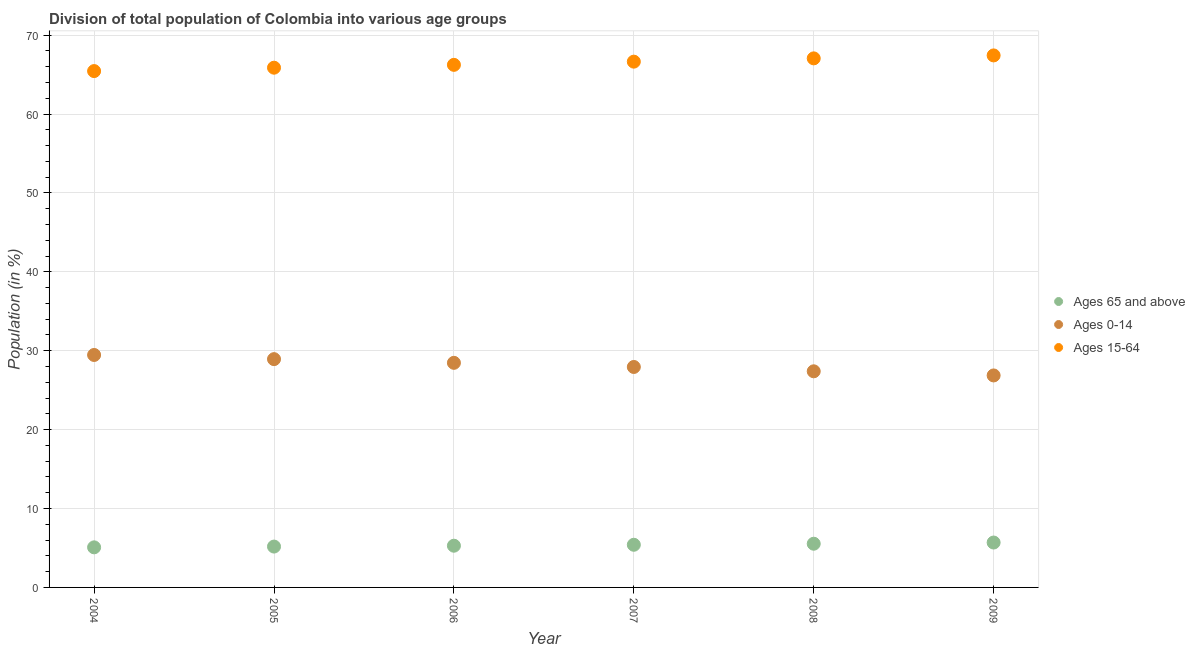How many different coloured dotlines are there?
Provide a succinct answer. 3. Is the number of dotlines equal to the number of legend labels?
Offer a terse response. Yes. What is the percentage of population within the age-group 0-14 in 2005?
Provide a succinct answer. 28.94. Across all years, what is the maximum percentage of population within the age-group 0-14?
Provide a succinct answer. 29.47. Across all years, what is the minimum percentage of population within the age-group 0-14?
Your answer should be compact. 26.87. In which year was the percentage of population within the age-group of 65 and above maximum?
Your response must be concise. 2009. What is the total percentage of population within the age-group 15-64 in the graph?
Give a very brief answer. 398.73. What is the difference between the percentage of population within the age-group 0-14 in 2004 and that in 2008?
Your answer should be compact. 2.07. What is the difference between the percentage of population within the age-group 15-64 in 2006 and the percentage of population within the age-group of 65 and above in 2004?
Your answer should be compact. 61.16. What is the average percentage of population within the age-group 0-14 per year?
Ensure brevity in your answer.  28.18. In the year 2005, what is the difference between the percentage of population within the age-group 15-64 and percentage of population within the age-group of 65 and above?
Your response must be concise. 60.7. In how many years, is the percentage of population within the age-group of 65 and above greater than 8 %?
Give a very brief answer. 0. What is the ratio of the percentage of population within the age-group 0-14 in 2007 to that in 2008?
Offer a terse response. 1.02. What is the difference between the highest and the second highest percentage of population within the age-group 15-64?
Give a very brief answer. 0.37. What is the difference between the highest and the lowest percentage of population within the age-group 0-14?
Provide a short and direct response. 2.59. In how many years, is the percentage of population within the age-group of 65 and above greater than the average percentage of population within the age-group of 65 and above taken over all years?
Your response must be concise. 3. Is the sum of the percentage of population within the age-group 15-64 in 2005 and 2008 greater than the maximum percentage of population within the age-group of 65 and above across all years?
Provide a short and direct response. Yes. Is it the case that in every year, the sum of the percentage of population within the age-group of 65 and above and percentage of population within the age-group 0-14 is greater than the percentage of population within the age-group 15-64?
Make the answer very short. No. Does the percentage of population within the age-group 0-14 monotonically increase over the years?
Your answer should be compact. No. Is the percentage of population within the age-group 0-14 strictly greater than the percentage of population within the age-group of 65 and above over the years?
Ensure brevity in your answer.  Yes. How many dotlines are there?
Keep it short and to the point. 3. What is the difference between two consecutive major ticks on the Y-axis?
Ensure brevity in your answer.  10. Are the values on the major ticks of Y-axis written in scientific E-notation?
Ensure brevity in your answer.  No. Does the graph contain any zero values?
Offer a very short reply. No. Where does the legend appear in the graph?
Keep it short and to the point. Center right. What is the title of the graph?
Your answer should be compact. Division of total population of Colombia into various age groups
. What is the label or title of the X-axis?
Your answer should be compact. Year. What is the Population (in %) in Ages 65 and above in 2004?
Keep it short and to the point. 5.08. What is the Population (in %) of Ages 0-14 in 2004?
Provide a succinct answer. 29.47. What is the Population (in %) in Ages 15-64 in 2004?
Your answer should be compact. 65.45. What is the Population (in %) of Ages 65 and above in 2005?
Provide a succinct answer. 5.18. What is the Population (in %) of Ages 0-14 in 2005?
Provide a short and direct response. 28.94. What is the Population (in %) of Ages 15-64 in 2005?
Offer a terse response. 65.88. What is the Population (in %) of Ages 65 and above in 2006?
Keep it short and to the point. 5.29. What is the Population (in %) in Ages 0-14 in 2006?
Your answer should be compact. 28.47. What is the Population (in %) of Ages 15-64 in 2006?
Provide a short and direct response. 66.24. What is the Population (in %) of Ages 65 and above in 2007?
Make the answer very short. 5.41. What is the Population (in %) of Ages 0-14 in 2007?
Keep it short and to the point. 27.95. What is the Population (in %) of Ages 15-64 in 2007?
Offer a very short reply. 66.65. What is the Population (in %) in Ages 65 and above in 2008?
Ensure brevity in your answer.  5.54. What is the Population (in %) in Ages 0-14 in 2008?
Your answer should be compact. 27.4. What is the Population (in %) in Ages 15-64 in 2008?
Your response must be concise. 67.06. What is the Population (in %) in Ages 65 and above in 2009?
Make the answer very short. 5.69. What is the Population (in %) in Ages 0-14 in 2009?
Provide a short and direct response. 26.87. What is the Population (in %) of Ages 15-64 in 2009?
Make the answer very short. 67.44. Across all years, what is the maximum Population (in %) in Ages 65 and above?
Give a very brief answer. 5.69. Across all years, what is the maximum Population (in %) of Ages 0-14?
Your answer should be very brief. 29.47. Across all years, what is the maximum Population (in %) of Ages 15-64?
Offer a terse response. 67.44. Across all years, what is the minimum Population (in %) of Ages 65 and above?
Keep it short and to the point. 5.08. Across all years, what is the minimum Population (in %) in Ages 0-14?
Your answer should be very brief. 26.87. Across all years, what is the minimum Population (in %) of Ages 15-64?
Provide a succinct answer. 65.45. What is the total Population (in %) of Ages 65 and above in the graph?
Give a very brief answer. 32.19. What is the total Population (in %) of Ages 0-14 in the graph?
Your answer should be very brief. 169.09. What is the total Population (in %) of Ages 15-64 in the graph?
Give a very brief answer. 398.73. What is the difference between the Population (in %) in Ages 65 and above in 2004 and that in 2005?
Your response must be concise. -0.1. What is the difference between the Population (in %) of Ages 0-14 in 2004 and that in 2005?
Offer a terse response. 0.53. What is the difference between the Population (in %) in Ages 15-64 in 2004 and that in 2005?
Make the answer very short. -0.43. What is the difference between the Population (in %) in Ages 65 and above in 2004 and that in 2006?
Offer a very short reply. -0.21. What is the difference between the Population (in %) in Ages 15-64 in 2004 and that in 2006?
Offer a very short reply. -0.79. What is the difference between the Population (in %) of Ages 65 and above in 2004 and that in 2007?
Make the answer very short. -0.33. What is the difference between the Population (in %) of Ages 0-14 in 2004 and that in 2007?
Make the answer very short. 1.52. What is the difference between the Population (in %) of Ages 15-64 in 2004 and that in 2007?
Your response must be concise. -1.2. What is the difference between the Population (in %) in Ages 65 and above in 2004 and that in 2008?
Your answer should be very brief. -0.46. What is the difference between the Population (in %) of Ages 0-14 in 2004 and that in 2008?
Ensure brevity in your answer.  2.07. What is the difference between the Population (in %) of Ages 15-64 in 2004 and that in 2008?
Provide a short and direct response. -1.61. What is the difference between the Population (in %) of Ages 65 and above in 2004 and that in 2009?
Your response must be concise. -0.61. What is the difference between the Population (in %) of Ages 0-14 in 2004 and that in 2009?
Offer a very short reply. 2.59. What is the difference between the Population (in %) in Ages 15-64 in 2004 and that in 2009?
Make the answer very short. -1.99. What is the difference between the Population (in %) of Ages 65 and above in 2005 and that in 2006?
Your response must be concise. -0.11. What is the difference between the Population (in %) in Ages 0-14 in 2005 and that in 2006?
Provide a succinct answer. 0.47. What is the difference between the Population (in %) of Ages 15-64 in 2005 and that in 2006?
Provide a short and direct response. -0.36. What is the difference between the Population (in %) in Ages 65 and above in 2005 and that in 2007?
Give a very brief answer. -0.23. What is the difference between the Population (in %) in Ages 0-14 in 2005 and that in 2007?
Your response must be concise. 0.99. What is the difference between the Population (in %) in Ages 15-64 in 2005 and that in 2007?
Your response must be concise. -0.77. What is the difference between the Population (in %) of Ages 65 and above in 2005 and that in 2008?
Your response must be concise. -0.36. What is the difference between the Population (in %) in Ages 0-14 in 2005 and that in 2008?
Give a very brief answer. 1.54. What is the difference between the Population (in %) in Ages 15-64 in 2005 and that in 2008?
Your response must be concise. -1.18. What is the difference between the Population (in %) in Ages 65 and above in 2005 and that in 2009?
Your answer should be very brief. -0.51. What is the difference between the Population (in %) of Ages 0-14 in 2005 and that in 2009?
Offer a terse response. 2.07. What is the difference between the Population (in %) in Ages 15-64 in 2005 and that in 2009?
Provide a short and direct response. -1.56. What is the difference between the Population (in %) of Ages 65 and above in 2006 and that in 2007?
Your answer should be compact. -0.12. What is the difference between the Population (in %) in Ages 0-14 in 2006 and that in 2007?
Offer a very short reply. 0.52. What is the difference between the Population (in %) in Ages 15-64 in 2006 and that in 2007?
Your answer should be very brief. -0.41. What is the difference between the Population (in %) in Ages 65 and above in 2006 and that in 2008?
Ensure brevity in your answer.  -0.25. What is the difference between the Population (in %) in Ages 0-14 in 2006 and that in 2008?
Provide a succinct answer. 1.07. What is the difference between the Population (in %) of Ages 15-64 in 2006 and that in 2008?
Keep it short and to the point. -0.82. What is the difference between the Population (in %) of Ages 65 and above in 2006 and that in 2009?
Offer a very short reply. -0.4. What is the difference between the Population (in %) in Ages 0-14 in 2006 and that in 2009?
Ensure brevity in your answer.  1.6. What is the difference between the Population (in %) of Ages 15-64 in 2006 and that in 2009?
Keep it short and to the point. -1.2. What is the difference between the Population (in %) of Ages 65 and above in 2007 and that in 2008?
Offer a terse response. -0.13. What is the difference between the Population (in %) of Ages 0-14 in 2007 and that in 2008?
Your response must be concise. 0.55. What is the difference between the Population (in %) of Ages 15-64 in 2007 and that in 2008?
Ensure brevity in your answer.  -0.42. What is the difference between the Population (in %) in Ages 65 and above in 2007 and that in 2009?
Provide a short and direct response. -0.28. What is the difference between the Population (in %) in Ages 0-14 in 2007 and that in 2009?
Your response must be concise. 1.07. What is the difference between the Population (in %) in Ages 15-64 in 2007 and that in 2009?
Give a very brief answer. -0.79. What is the difference between the Population (in %) of Ages 65 and above in 2008 and that in 2009?
Make the answer very short. -0.15. What is the difference between the Population (in %) of Ages 0-14 in 2008 and that in 2009?
Make the answer very short. 0.52. What is the difference between the Population (in %) in Ages 15-64 in 2008 and that in 2009?
Your answer should be compact. -0.37. What is the difference between the Population (in %) of Ages 65 and above in 2004 and the Population (in %) of Ages 0-14 in 2005?
Make the answer very short. -23.86. What is the difference between the Population (in %) in Ages 65 and above in 2004 and the Population (in %) in Ages 15-64 in 2005?
Ensure brevity in your answer.  -60.8. What is the difference between the Population (in %) in Ages 0-14 in 2004 and the Population (in %) in Ages 15-64 in 2005?
Give a very brief answer. -36.42. What is the difference between the Population (in %) of Ages 65 and above in 2004 and the Population (in %) of Ages 0-14 in 2006?
Provide a succinct answer. -23.39. What is the difference between the Population (in %) in Ages 65 and above in 2004 and the Population (in %) in Ages 15-64 in 2006?
Provide a short and direct response. -61.16. What is the difference between the Population (in %) of Ages 0-14 in 2004 and the Population (in %) of Ages 15-64 in 2006?
Offer a terse response. -36.78. What is the difference between the Population (in %) of Ages 65 and above in 2004 and the Population (in %) of Ages 0-14 in 2007?
Provide a short and direct response. -22.86. What is the difference between the Population (in %) of Ages 65 and above in 2004 and the Population (in %) of Ages 15-64 in 2007?
Your answer should be compact. -61.57. What is the difference between the Population (in %) in Ages 0-14 in 2004 and the Population (in %) in Ages 15-64 in 2007?
Offer a very short reply. -37.18. What is the difference between the Population (in %) of Ages 65 and above in 2004 and the Population (in %) of Ages 0-14 in 2008?
Your response must be concise. -22.32. What is the difference between the Population (in %) of Ages 65 and above in 2004 and the Population (in %) of Ages 15-64 in 2008?
Keep it short and to the point. -61.98. What is the difference between the Population (in %) in Ages 0-14 in 2004 and the Population (in %) in Ages 15-64 in 2008?
Make the answer very short. -37.6. What is the difference between the Population (in %) in Ages 65 and above in 2004 and the Population (in %) in Ages 0-14 in 2009?
Make the answer very short. -21.79. What is the difference between the Population (in %) of Ages 65 and above in 2004 and the Population (in %) of Ages 15-64 in 2009?
Provide a succinct answer. -62.36. What is the difference between the Population (in %) of Ages 0-14 in 2004 and the Population (in %) of Ages 15-64 in 2009?
Your answer should be very brief. -37.97. What is the difference between the Population (in %) of Ages 65 and above in 2005 and the Population (in %) of Ages 0-14 in 2006?
Make the answer very short. -23.29. What is the difference between the Population (in %) in Ages 65 and above in 2005 and the Population (in %) in Ages 15-64 in 2006?
Your response must be concise. -61.06. What is the difference between the Population (in %) in Ages 0-14 in 2005 and the Population (in %) in Ages 15-64 in 2006?
Your response must be concise. -37.3. What is the difference between the Population (in %) of Ages 65 and above in 2005 and the Population (in %) of Ages 0-14 in 2007?
Your answer should be compact. -22.77. What is the difference between the Population (in %) in Ages 65 and above in 2005 and the Population (in %) in Ages 15-64 in 2007?
Provide a succinct answer. -61.47. What is the difference between the Population (in %) in Ages 0-14 in 2005 and the Population (in %) in Ages 15-64 in 2007?
Ensure brevity in your answer.  -37.71. What is the difference between the Population (in %) in Ages 65 and above in 2005 and the Population (in %) in Ages 0-14 in 2008?
Ensure brevity in your answer.  -22.22. What is the difference between the Population (in %) in Ages 65 and above in 2005 and the Population (in %) in Ages 15-64 in 2008?
Provide a short and direct response. -61.88. What is the difference between the Population (in %) of Ages 0-14 in 2005 and the Population (in %) of Ages 15-64 in 2008?
Give a very brief answer. -38.12. What is the difference between the Population (in %) in Ages 65 and above in 2005 and the Population (in %) in Ages 0-14 in 2009?
Offer a very short reply. -21.69. What is the difference between the Population (in %) in Ages 65 and above in 2005 and the Population (in %) in Ages 15-64 in 2009?
Your response must be concise. -62.26. What is the difference between the Population (in %) of Ages 0-14 in 2005 and the Population (in %) of Ages 15-64 in 2009?
Give a very brief answer. -38.5. What is the difference between the Population (in %) of Ages 65 and above in 2006 and the Population (in %) of Ages 0-14 in 2007?
Ensure brevity in your answer.  -22.66. What is the difference between the Population (in %) of Ages 65 and above in 2006 and the Population (in %) of Ages 15-64 in 2007?
Make the answer very short. -61.36. What is the difference between the Population (in %) of Ages 0-14 in 2006 and the Population (in %) of Ages 15-64 in 2007?
Make the answer very short. -38.18. What is the difference between the Population (in %) in Ages 65 and above in 2006 and the Population (in %) in Ages 0-14 in 2008?
Offer a very short reply. -22.11. What is the difference between the Population (in %) of Ages 65 and above in 2006 and the Population (in %) of Ages 15-64 in 2008?
Offer a terse response. -61.78. What is the difference between the Population (in %) of Ages 0-14 in 2006 and the Population (in %) of Ages 15-64 in 2008?
Make the answer very short. -38.59. What is the difference between the Population (in %) in Ages 65 and above in 2006 and the Population (in %) in Ages 0-14 in 2009?
Ensure brevity in your answer.  -21.58. What is the difference between the Population (in %) of Ages 65 and above in 2006 and the Population (in %) of Ages 15-64 in 2009?
Keep it short and to the point. -62.15. What is the difference between the Population (in %) of Ages 0-14 in 2006 and the Population (in %) of Ages 15-64 in 2009?
Give a very brief answer. -38.97. What is the difference between the Population (in %) in Ages 65 and above in 2007 and the Population (in %) in Ages 0-14 in 2008?
Keep it short and to the point. -21.99. What is the difference between the Population (in %) of Ages 65 and above in 2007 and the Population (in %) of Ages 15-64 in 2008?
Keep it short and to the point. -61.66. What is the difference between the Population (in %) of Ages 0-14 in 2007 and the Population (in %) of Ages 15-64 in 2008?
Ensure brevity in your answer.  -39.12. What is the difference between the Population (in %) in Ages 65 and above in 2007 and the Population (in %) in Ages 0-14 in 2009?
Provide a short and direct response. -21.46. What is the difference between the Population (in %) in Ages 65 and above in 2007 and the Population (in %) in Ages 15-64 in 2009?
Ensure brevity in your answer.  -62.03. What is the difference between the Population (in %) in Ages 0-14 in 2007 and the Population (in %) in Ages 15-64 in 2009?
Offer a very short reply. -39.49. What is the difference between the Population (in %) in Ages 65 and above in 2008 and the Population (in %) in Ages 0-14 in 2009?
Keep it short and to the point. -21.33. What is the difference between the Population (in %) in Ages 65 and above in 2008 and the Population (in %) in Ages 15-64 in 2009?
Offer a very short reply. -61.9. What is the difference between the Population (in %) in Ages 0-14 in 2008 and the Population (in %) in Ages 15-64 in 2009?
Offer a very short reply. -40.04. What is the average Population (in %) in Ages 65 and above per year?
Your answer should be compact. 5.36. What is the average Population (in %) in Ages 0-14 per year?
Give a very brief answer. 28.18. What is the average Population (in %) of Ages 15-64 per year?
Offer a very short reply. 66.45. In the year 2004, what is the difference between the Population (in %) in Ages 65 and above and Population (in %) in Ages 0-14?
Your answer should be compact. -24.39. In the year 2004, what is the difference between the Population (in %) of Ages 65 and above and Population (in %) of Ages 15-64?
Your response must be concise. -60.37. In the year 2004, what is the difference between the Population (in %) in Ages 0-14 and Population (in %) in Ages 15-64?
Offer a terse response. -35.99. In the year 2005, what is the difference between the Population (in %) in Ages 65 and above and Population (in %) in Ages 0-14?
Ensure brevity in your answer.  -23.76. In the year 2005, what is the difference between the Population (in %) of Ages 65 and above and Population (in %) of Ages 15-64?
Keep it short and to the point. -60.7. In the year 2005, what is the difference between the Population (in %) of Ages 0-14 and Population (in %) of Ages 15-64?
Offer a very short reply. -36.94. In the year 2006, what is the difference between the Population (in %) of Ages 65 and above and Population (in %) of Ages 0-14?
Give a very brief answer. -23.18. In the year 2006, what is the difference between the Population (in %) of Ages 65 and above and Population (in %) of Ages 15-64?
Offer a terse response. -60.95. In the year 2006, what is the difference between the Population (in %) of Ages 0-14 and Population (in %) of Ages 15-64?
Your answer should be very brief. -37.77. In the year 2007, what is the difference between the Population (in %) in Ages 65 and above and Population (in %) in Ages 0-14?
Give a very brief answer. -22.54. In the year 2007, what is the difference between the Population (in %) in Ages 65 and above and Population (in %) in Ages 15-64?
Your answer should be very brief. -61.24. In the year 2007, what is the difference between the Population (in %) of Ages 0-14 and Population (in %) of Ages 15-64?
Your response must be concise. -38.7. In the year 2008, what is the difference between the Population (in %) of Ages 65 and above and Population (in %) of Ages 0-14?
Offer a very short reply. -21.86. In the year 2008, what is the difference between the Population (in %) in Ages 65 and above and Population (in %) in Ages 15-64?
Your answer should be compact. -61.52. In the year 2008, what is the difference between the Population (in %) of Ages 0-14 and Population (in %) of Ages 15-64?
Keep it short and to the point. -39.67. In the year 2009, what is the difference between the Population (in %) in Ages 65 and above and Population (in %) in Ages 0-14?
Give a very brief answer. -21.18. In the year 2009, what is the difference between the Population (in %) of Ages 65 and above and Population (in %) of Ages 15-64?
Provide a succinct answer. -61.75. In the year 2009, what is the difference between the Population (in %) in Ages 0-14 and Population (in %) in Ages 15-64?
Offer a very short reply. -40.57. What is the ratio of the Population (in %) of Ages 65 and above in 2004 to that in 2005?
Offer a very short reply. 0.98. What is the ratio of the Population (in %) in Ages 0-14 in 2004 to that in 2005?
Provide a succinct answer. 1.02. What is the ratio of the Population (in %) of Ages 15-64 in 2004 to that in 2005?
Offer a terse response. 0.99. What is the ratio of the Population (in %) of Ages 65 and above in 2004 to that in 2006?
Make the answer very short. 0.96. What is the ratio of the Population (in %) in Ages 0-14 in 2004 to that in 2006?
Your response must be concise. 1.03. What is the ratio of the Population (in %) of Ages 15-64 in 2004 to that in 2006?
Offer a very short reply. 0.99. What is the ratio of the Population (in %) of Ages 65 and above in 2004 to that in 2007?
Offer a terse response. 0.94. What is the ratio of the Population (in %) in Ages 0-14 in 2004 to that in 2007?
Give a very brief answer. 1.05. What is the ratio of the Population (in %) of Ages 15-64 in 2004 to that in 2007?
Offer a very short reply. 0.98. What is the ratio of the Population (in %) in Ages 65 and above in 2004 to that in 2008?
Offer a terse response. 0.92. What is the ratio of the Population (in %) of Ages 0-14 in 2004 to that in 2008?
Your response must be concise. 1.08. What is the ratio of the Population (in %) of Ages 15-64 in 2004 to that in 2008?
Your answer should be very brief. 0.98. What is the ratio of the Population (in %) of Ages 65 and above in 2004 to that in 2009?
Provide a succinct answer. 0.89. What is the ratio of the Population (in %) of Ages 0-14 in 2004 to that in 2009?
Your answer should be compact. 1.1. What is the ratio of the Population (in %) in Ages 15-64 in 2004 to that in 2009?
Give a very brief answer. 0.97. What is the ratio of the Population (in %) in Ages 65 and above in 2005 to that in 2006?
Your response must be concise. 0.98. What is the ratio of the Population (in %) of Ages 0-14 in 2005 to that in 2006?
Offer a very short reply. 1.02. What is the ratio of the Population (in %) of Ages 15-64 in 2005 to that in 2006?
Your answer should be very brief. 0.99. What is the ratio of the Population (in %) in Ages 65 and above in 2005 to that in 2007?
Give a very brief answer. 0.96. What is the ratio of the Population (in %) of Ages 0-14 in 2005 to that in 2007?
Your answer should be compact. 1.04. What is the ratio of the Population (in %) of Ages 15-64 in 2005 to that in 2007?
Offer a very short reply. 0.99. What is the ratio of the Population (in %) in Ages 65 and above in 2005 to that in 2008?
Keep it short and to the point. 0.93. What is the ratio of the Population (in %) of Ages 0-14 in 2005 to that in 2008?
Provide a succinct answer. 1.06. What is the ratio of the Population (in %) of Ages 15-64 in 2005 to that in 2008?
Offer a terse response. 0.98. What is the ratio of the Population (in %) of Ages 65 and above in 2005 to that in 2009?
Make the answer very short. 0.91. What is the ratio of the Population (in %) of Ages 15-64 in 2005 to that in 2009?
Keep it short and to the point. 0.98. What is the ratio of the Population (in %) in Ages 65 and above in 2006 to that in 2007?
Offer a very short reply. 0.98. What is the ratio of the Population (in %) in Ages 0-14 in 2006 to that in 2007?
Offer a terse response. 1.02. What is the ratio of the Population (in %) in Ages 15-64 in 2006 to that in 2007?
Offer a terse response. 0.99. What is the ratio of the Population (in %) in Ages 65 and above in 2006 to that in 2008?
Make the answer very short. 0.95. What is the ratio of the Population (in %) in Ages 0-14 in 2006 to that in 2008?
Provide a short and direct response. 1.04. What is the ratio of the Population (in %) in Ages 65 and above in 2006 to that in 2009?
Offer a very short reply. 0.93. What is the ratio of the Population (in %) of Ages 0-14 in 2006 to that in 2009?
Offer a terse response. 1.06. What is the ratio of the Population (in %) of Ages 15-64 in 2006 to that in 2009?
Offer a very short reply. 0.98. What is the ratio of the Population (in %) of Ages 15-64 in 2007 to that in 2008?
Provide a short and direct response. 0.99. What is the ratio of the Population (in %) in Ages 65 and above in 2007 to that in 2009?
Offer a terse response. 0.95. What is the ratio of the Population (in %) in Ages 0-14 in 2007 to that in 2009?
Give a very brief answer. 1.04. What is the ratio of the Population (in %) in Ages 15-64 in 2007 to that in 2009?
Your answer should be compact. 0.99. What is the ratio of the Population (in %) of Ages 65 and above in 2008 to that in 2009?
Give a very brief answer. 0.97. What is the ratio of the Population (in %) in Ages 0-14 in 2008 to that in 2009?
Provide a succinct answer. 1.02. What is the difference between the highest and the second highest Population (in %) in Ages 65 and above?
Provide a short and direct response. 0.15. What is the difference between the highest and the second highest Population (in %) in Ages 0-14?
Provide a short and direct response. 0.53. What is the difference between the highest and the second highest Population (in %) in Ages 15-64?
Provide a short and direct response. 0.37. What is the difference between the highest and the lowest Population (in %) of Ages 65 and above?
Provide a short and direct response. 0.61. What is the difference between the highest and the lowest Population (in %) of Ages 0-14?
Your answer should be compact. 2.59. What is the difference between the highest and the lowest Population (in %) of Ages 15-64?
Your answer should be very brief. 1.99. 